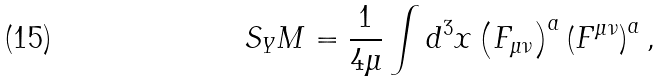Convert formula to latex. <formula><loc_0><loc_0><loc_500><loc_500>S _ { Y } M = \frac { 1 } { 4 \mu } \int d ^ { 3 } x \left ( F _ { \mu \nu } \right ) ^ { a } \left ( F ^ { \mu \nu } \right ) ^ { a } ,</formula> 